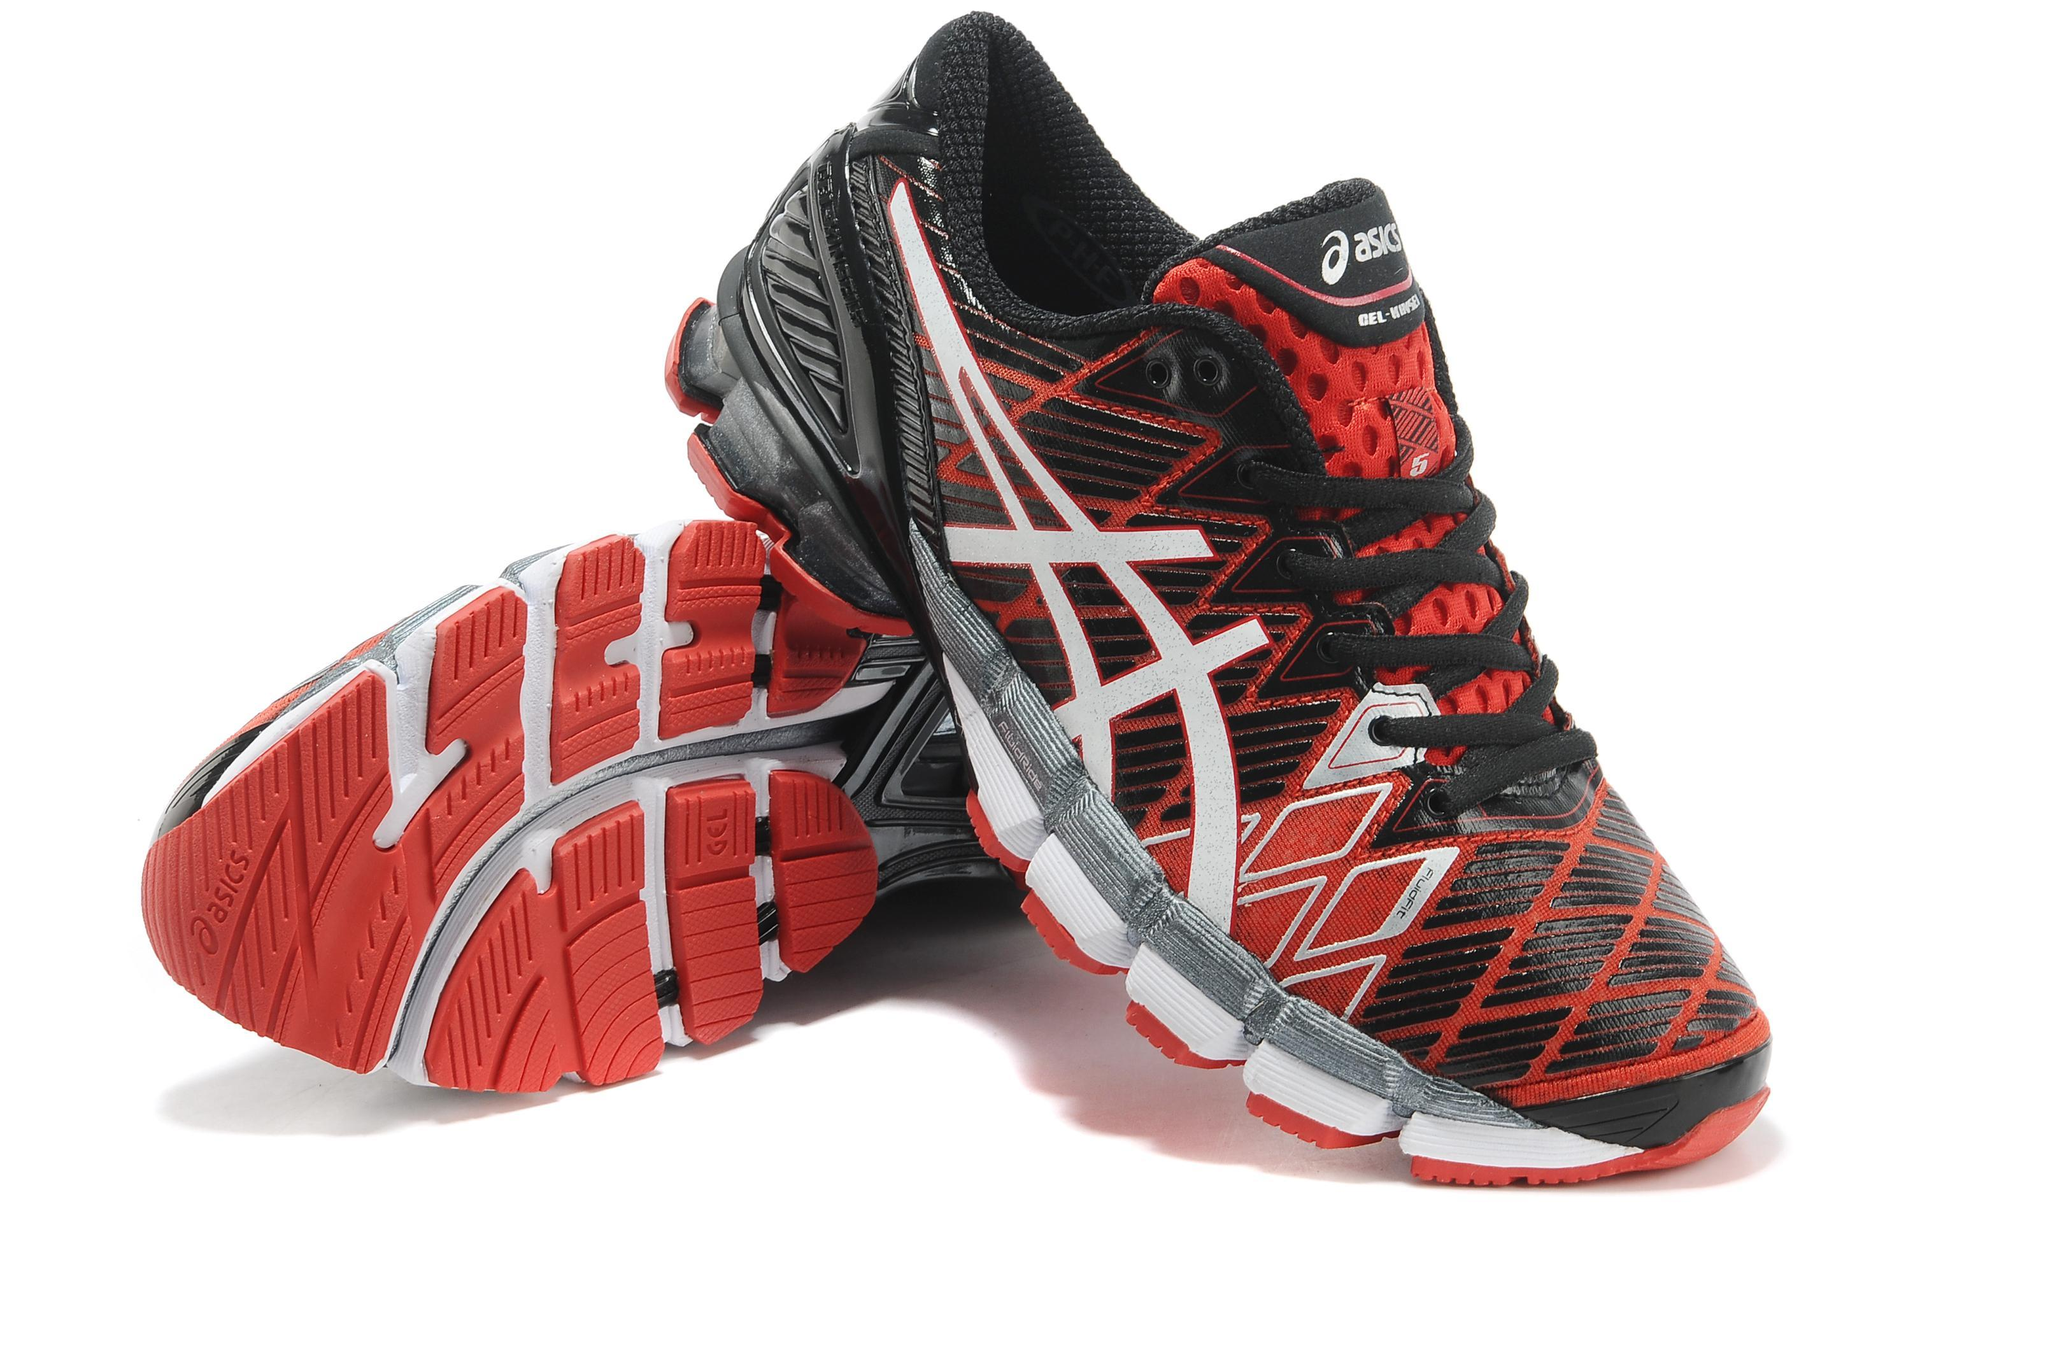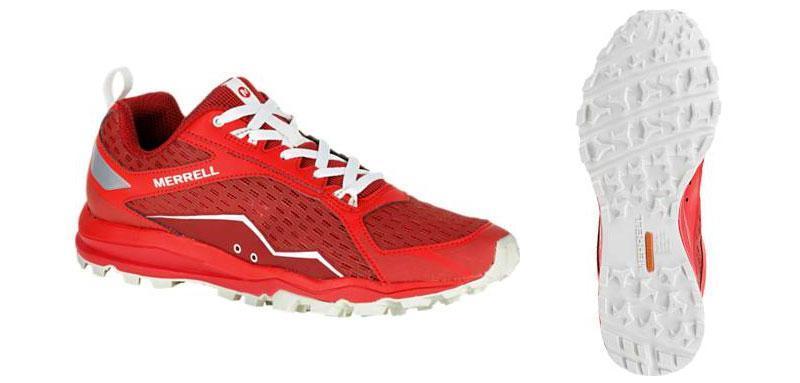The first image is the image on the left, the second image is the image on the right. Examine the images to the left and right. Is the description "One of the images is a single shoe facing left." accurate? Answer yes or no. No. The first image is the image on the left, the second image is the image on the right. For the images displayed, is the sentence "One image contains a single sneaker, and the other shows a pair of sneakers displayed with a sole-first shoe on its side and a rightside-up shoe leaning in front of it." factually correct? Answer yes or no. No. 